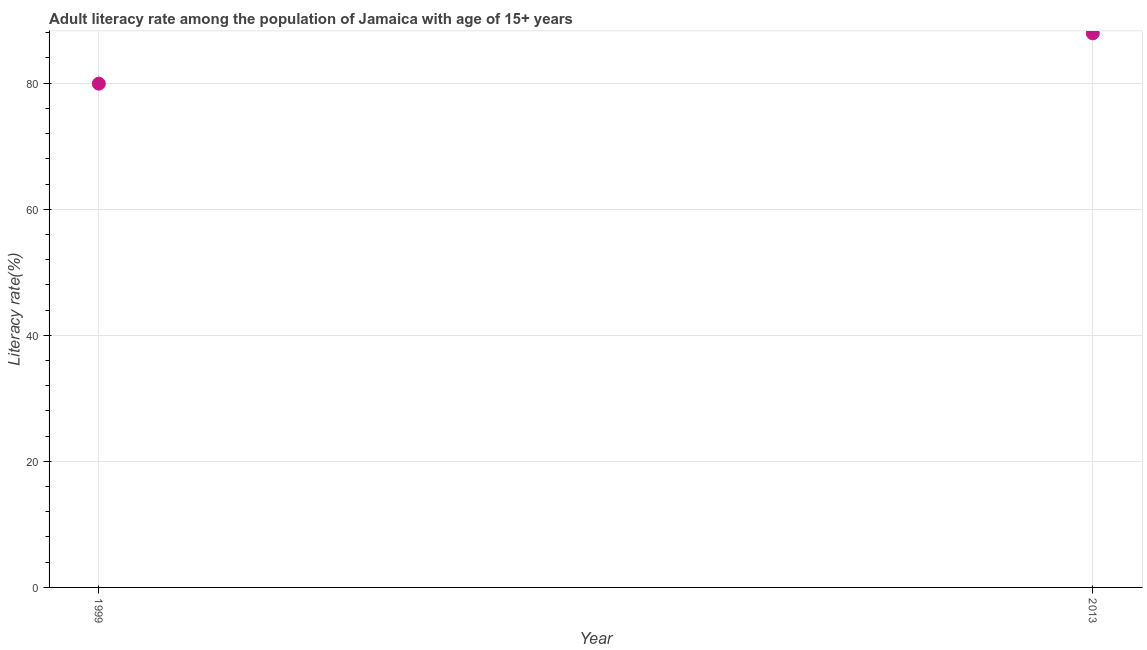What is the adult literacy rate in 2013?
Your response must be concise. 87.9. Across all years, what is the maximum adult literacy rate?
Give a very brief answer. 87.9. Across all years, what is the minimum adult literacy rate?
Keep it short and to the point. 79.92. In which year was the adult literacy rate maximum?
Provide a succinct answer. 2013. What is the sum of the adult literacy rate?
Offer a terse response. 167.82. What is the difference between the adult literacy rate in 1999 and 2013?
Keep it short and to the point. -7.98. What is the average adult literacy rate per year?
Your response must be concise. 83.91. What is the median adult literacy rate?
Ensure brevity in your answer.  83.91. In how many years, is the adult literacy rate greater than 28 %?
Provide a short and direct response. 2. What is the ratio of the adult literacy rate in 1999 to that in 2013?
Provide a short and direct response. 0.91. Is the adult literacy rate in 1999 less than that in 2013?
Offer a very short reply. Yes. How many dotlines are there?
Make the answer very short. 1. How many years are there in the graph?
Ensure brevity in your answer.  2. What is the difference between two consecutive major ticks on the Y-axis?
Ensure brevity in your answer.  20. Are the values on the major ticks of Y-axis written in scientific E-notation?
Give a very brief answer. No. What is the title of the graph?
Your answer should be very brief. Adult literacy rate among the population of Jamaica with age of 15+ years. What is the label or title of the Y-axis?
Provide a short and direct response. Literacy rate(%). What is the Literacy rate(%) in 1999?
Your answer should be compact. 79.92. What is the Literacy rate(%) in 2013?
Offer a terse response. 87.9. What is the difference between the Literacy rate(%) in 1999 and 2013?
Your answer should be very brief. -7.98. What is the ratio of the Literacy rate(%) in 1999 to that in 2013?
Make the answer very short. 0.91. 